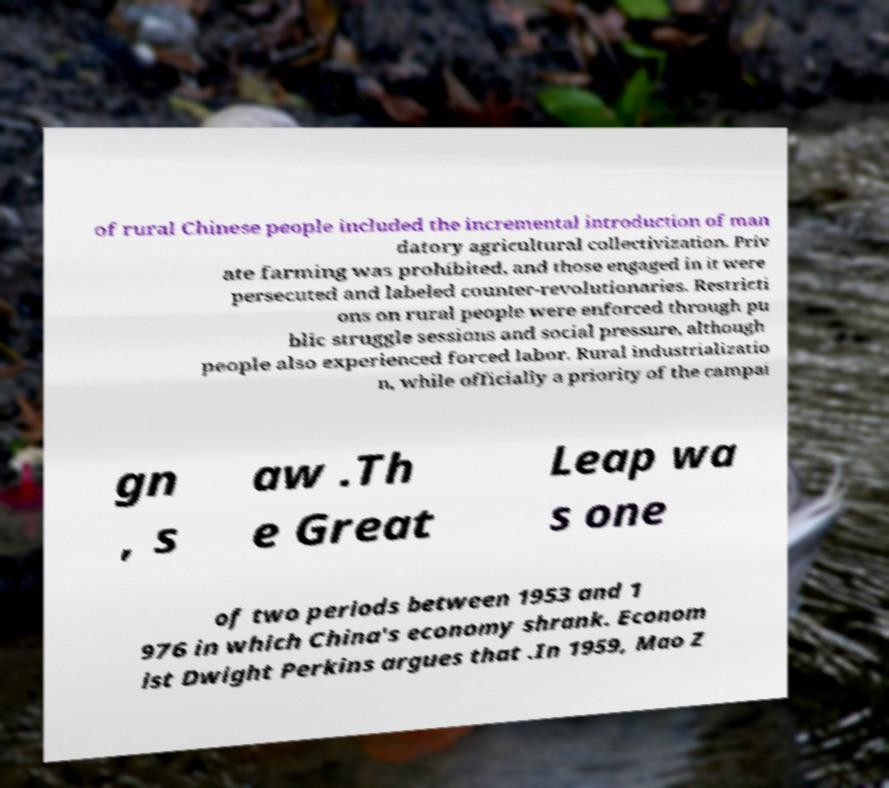I need the written content from this picture converted into text. Can you do that? of rural Chinese people included the incremental introduction of man datory agricultural collectivization. Priv ate farming was prohibited, and those engaged in it were persecuted and labeled counter-revolutionaries. Restricti ons on rural people were enforced through pu blic struggle sessions and social pressure, although people also experienced forced labor. Rural industrializatio n, while officially a priority of the campai gn , s aw .Th e Great Leap wa s one of two periods between 1953 and 1 976 in which China's economy shrank. Econom ist Dwight Perkins argues that .In 1959, Mao Z 